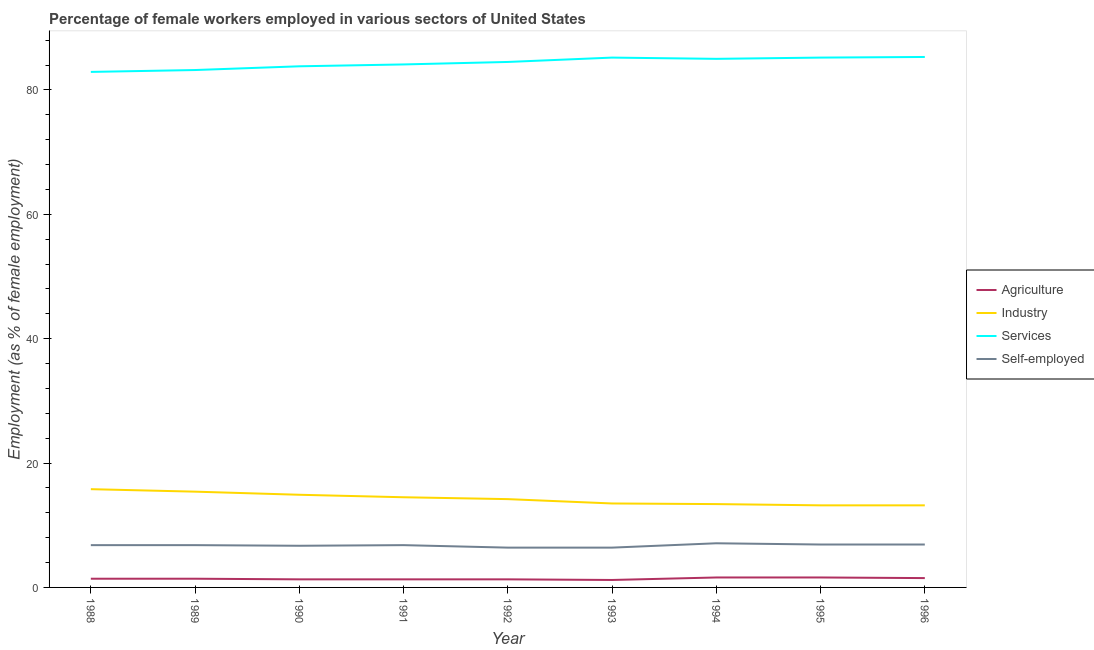Does the line corresponding to percentage of self employed female workers intersect with the line corresponding to percentage of female workers in industry?
Give a very brief answer. No. Is the number of lines equal to the number of legend labels?
Ensure brevity in your answer.  Yes. Across all years, what is the maximum percentage of self employed female workers?
Ensure brevity in your answer.  7.1. Across all years, what is the minimum percentage of female workers in industry?
Make the answer very short. 13.2. In which year was the percentage of female workers in agriculture maximum?
Ensure brevity in your answer.  1994. What is the total percentage of female workers in industry in the graph?
Give a very brief answer. 128.1. What is the difference between the percentage of female workers in industry in 1994 and that in 1995?
Your response must be concise. 0.2. What is the difference between the percentage of female workers in agriculture in 1988 and the percentage of self employed female workers in 1991?
Your answer should be compact. -5.4. What is the average percentage of female workers in industry per year?
Your answer should be very brief. 14.23. In the year 1996, what is the difference between the percentage of female workers in agriculture and percentage of female workers in industry?
Provide a succinct answer. -11.7. In how many years, is the percentage of female workers in services greater than 48 %?
Give a very brief answer. 9. What is the ratio of the percentage of female workers in services in 1990 to that in 1992?
Make the answer very short. 0.99. Is the difference between the percentage of female workers in industry in 1991 and 1996 greater than the difference between the percentage of female workers in services in 1991 and 1996?
Give a very brief answer. Yes. What is the difference between the highest and the second highest percentage of female workers in services?
Provide a succinct answer. 0.1. What is the difference between the highest and the lowest percentage of female workers in agriculture?
Your response must be concise. 0.4. In how many years, is the percentage of female workers in agriculture greater than the average percentage of female workers in agriculture taken over all years?
Your answer should be compact. 3. Is it the case that in every year, the sum of the percentage of female workers in services and percentage of self employed female workers is greater than the sum of percentage of female workers in industry and percentage of female workers in agriculture?
Keep it short and to the point. No. Is it the case that in every year, the sum of the percentage of female workers in agriculture and percentage of female workers in industry is greater than the percentage of female workers in services?
Keep it short and to the point. No. Does the percentage of female workers in industry monotonically increase over the years?
Offer a very short reply. No. Is the percentage of female workers in services strictly less than the percentage of female workers in industry over the years?
Give a very brief answer. No. What is the difference between two consecutive major ticks on the Y-axis?
Give a very brief answer. 20. Does the graph contain any zero values?
Your answer should be compact. No. Where does the legend appear in the graph?
Your answer should be compact. Center right. How many legend labels are there?
Provide a succinct answer. 4. What is the title of the graph?
Your answer should be compact. Percentage of female workers employed in various sectors of United States. What is the label or title of the X-axis?
Provide a short and direct response. Year. What is the label or title of the Y-axis?
Offer a very short reply. Employment (as % of female employment). What is the Employment (as % of female employment) of Agriculture in 1988?
Give a very brief answer. 1.4. What is the Employment (as % of female employment) of Industry in 1988?
Provide a short and direct response. 15.8. What is the Employment (as % of female employment) in Services in 1988?
Your response must be concise. 82.9. What is the Employment (as % of female employment) in Self-employed in 1988?
Make the answer very short. 6.8. What is the Employment (as % of female employment) in Agriculture in 1989?
Your answer should be very brief. 1.4. What is the Employment (as % of female employment) in Industry in 1989?
Provide a succinct answer. 15.4. What is the Employment (as % of female employment) of Services in 1989?
Your answer should be compact. 83.2. What is the Employment (as % of female employment) of Self-employed in 1989?
Make the answer very short. 6.8. What is the Employment (as % of female employment) of Agriculture in 1990?
Provide a short and direct response. 1.3. What is the Employment (as % of female employment) in Industry in 1990?
Ensure brevity in your answer.  14.9. What is the Employment (as % of female employment) in Services in 1990?
Ensure brevity in your answer.  83.8. What is the Employment (as % of female employment) in Self-employed in 1990?
Your answer should be compact. 6.7. What is the Employment (as % of female employment) of Agriculture in 1991?
Keep it short and to the point. 1.3. What is the Employment (as % of female employment) of Services in 1991?
Provide a short and direct response. 84.1. What is the Employment (as % of female employment) of Self-employed in 1991?
Your response must be concise. 6.8. What is the Employment (as % of female employment) in Agriculture in 1992?
Your answer should be compact. 1.3. What is the Employment (as % of female employment) in Industry in 1992?
Offer a very short reply. 14.2. What is the Employment (as % of female employment) of Services in 1992?
Offer a terse response. 84.5. What is the Employment (as % of female employment) of Self-employed in 1992?
Ensure brevity in your answer.  6.4. What is the Employment (as % of female employment) of Agriculture in 1993?
Provide a short and direct response. 1.2. What is the Employment (as % of female employment) in Industry in 1993?
Your response must be concise. 13.5. What is the Employment (as % of female employment) in Services in 1993?
Your answer should be very brief. 85.2. What is the Employment (as % of female employment) in Self-employed in 1993?
Ensure brevity in your answer.  6.4. What is the Employment (as % of female employment) of Agriculture in 1994?
Make the answer very short. 1.6. What is the Employment (as % of female employment) of Industry in 1994?
Ensure brevity in your answer.  13.4. What is the Employment (as % of female employment) in Self-employed in 1994?
Offer a terse response. 7.1. What is the Employment (as % of female employment) of Agriculture in 1995?
Give a very brief answer. 1.6. What is the Employment (as % of female employment) of Industry in 1995?
Make the answer very short. 13.2. What is the Employment (as % of female employment) of Services in 1995?
Give a very brief answer. 85.2. What is the Employment (as % of female employment) in Self-employed in 1995?
Make the answer very short. 6.9. What is the Employment (as % of female employment) of Industry in 1996?
Offer a very short reply. 13.2. What is the Employment (as % of female employment) of Services in 1996?
Give a very brief answer. 85.3. What is the Employment (as % of female employment) of Self-employed in 1996?
Your response must be concise. 6.9. Across all years, what is the maximum Employment (as % of female employment) in Agriculture?
Your answer should be compact. 1.6. Across all years, what is the maximum Employment (as % of female employment) of Industry?
Provide a succinct answer. 15.8. Across all years, what is the maximum Employment (as % of female employment) in Services?
Offer a terse response. 85.3. Across all years, what is the maximum Employment (as % of female employment) of Self-employed?
Offer a very short reply. 7.1. Across all years, what is the minimum Employment (as % of female employment) of Agriculture?
Provide a short and direct response. 1.2. Across all years, what is the minimum Employment (as % of female employment) in Industry?
Your answer should be compact. 13.2. Across all years, what is the minimum Employment (as % of female employment) of Services?
Provide a short and direct response. 82.9. Across all years, what is the minimum Employment (as % of female employment) in Self-employed?
Provide a succinct answer. 6.4. What is the total Employment (as % of female employment) in Industry in the graph?
Provide a short and direct response. 128.1. What is the total Employment (as % of female employment) in Services in the graph?
Ensure brevity in your answer.  759.2. What is the total Employment (as % of female employment) of Self-employed in the graph?
Ensure brevity in your answer.  60.8. What is the difference between the Employment (as % of female employment) of Agriculture in 1988 and that in 1989?
Your response must be concise. 0. What is the difference between the Employment (as % of female employment) of Industry in 1988 and that in 1989?
Ensure brevity in your answer.  0.4. What is the difference between the Employment (as % of female employment) in Services in 1988 and that in 1989?
Keep it short and to the point. -0.3. What is the difference between the Employment (as % of female employment) in Self-employed in 1988 and that in 1990?
Give a very brief answer. 0.1. What is the difference between the Employment (as % of female employment) in Agriculture in 1988 and that in 1991?
Provide a short and direct response. 0.1. What is the difference between the Employment (as % of female employment) of Industry in 1988 and that in 1991?
Your answer should be compact. 1.3. What is the difference between the Employment (as % of female employment) of Industry in 1988 and that in 1992?
Provide a succinct answer. 1.6. What is the difference between the Employment (as % of female employment) in Services in 1988 and that in 1992?
Offer a very short reply. -1.6. What is the difference between the Employment (as % of female employment) in Self-employed in 1988 and that in 1992?
Give a very brief answer. 0.4. What is the difference between the Employment (as % of female employment) in Services in 1988 and that in 1993?
Provide a succinct answer. -2.3. What is the difference between the Employment (as % of female employment) in Self-employed in 1988 and that in 1993?
Ensure brevity in your answer.  0.4. What is the difference between the Employment (as % of female employment) of Services in 1988 and that in 1994?
Keep it short and to the point. -2.1. What is the difference between the Employment (as % of female employment) in Industry in 1988 and that in 1995?
Ensure brevity in your answer.  2.6. What is the difference between the Employment (as % of female employment) of Self-employed in 1988 and that in 1995?
Ensure brevity in your answer.  -0.1. What is the difference between the Employment (as % of female employment) in Self-employed in 1988 and that in 1996?
Offer a terse response. -0.1. What is the difference between the Employment (as % of female employment) in Agriculture in 1989 and that in 1990?
Ensure brevity in your answer.  0.1. What is the difference between the Employment (as % of female employment) of Industry in 1989 and that in 1990?
Your answer should be compact. 0.5. What is the difference between the Employment (as % of female employment) of Services in 1989 and that in 1990?
Offer a very short reply. -0.6. What is the difference between the Employment (as % of female employment) in Self-employed in 1989 and that in 1990?
Your answer should be very brief. 0.1. What is the difference between the Employment (as % of female employment) of Agriculture in 1989 and that in 1991?
Provide a short and direct response. 0.1. What is the difference between the Employment (as % of female employment) in Industry in 1989 and that in 1991?
Offer a terse response. 0.9. What is the difference between the Employment (as % of female employment) of Services in 1989 and that in 1991?
Ensure brevity in your answer.  -0.9. What is the difference between the Employment (as % of female employment) in Agriculture in 1989 and that in 1992?
Keep it short and to the point. 0.1. What is the difference between the Employment (as % of female employment) in Services in 1989 and that in 1992?
Offer a terse response. -1.3. What is the difference between the Employment (as % of female employment) of Self-employed in 1989 and that in 1992?
Your answer should be compact. 0.4. What is the difference between the Employment (as % of female employment) of Industry in 1989 and that in 1994?
Your answer should be compact. 2. What is the difference between the Employment (as % of female employment) in Services in 1989 and that in 1995?
Offer a very short reply. -2. What is the difference between the Employment (as % of female employment) of Self-employed in 1989 and that in 1995?
Your response must be concise. -0.1. What is the difference between the Employment (as % of female employment) of Industry in 1989 and that in 1996?
Provide a succinct answer. 2.2. What is the difference between the Employment (as % of female employment) in Industry in 1990 and that in 1991?
Offer a very short reply. 0.4. What is the difference between the Employment (as % of female employment) of Agriculture in 1990 and that in 1992?
Ensure brevity in your answer.  0. What is the difference between the Employment (as % of female employment) of Services in 1990 and that in 1992?
Provide a short and direct response. -0.7. What is the difference between the Employment (as % of female employment) in Agriculture in 1990 and that in 1993?
Ensure brevity in your answer.  0.1. What is the difference between the Employment (as % of female employment) of Self-employed in 1990 and that in 1993?
Make the answer very short. 0.3. What is the difference between the Employment (as % of female employment) of Services in 1990 and that in 1994?
Your answer should be compact. -1.2. What is the difference between the Employment (as % of female employment) of Agriculture in 1990 and that in 1996?
Give a very brief answer. -0.2. What is the difference between the Employment (as % of female employment) of Services in 1990 and that in 1996?
Make the answer very short. -1.5. What is the difference between the Employment (as % of female employment) of Self-employed in 1990 and that in 1996?
Offer a terse response. -0.2. What is the difference between the Employment (as % of female employment) in Industry in 1991 and that in 1992?
Your answer should be compact. 0.3. What is the difference between the Employment (as % of female employment) in Agriculture in 1991 and that in 1993?
Your response must be concise. 0.1. What is the difference between the Employment (as % of female employment) of Industry in 1991 and that in 1993?
Offer a very short reply. 1. What is the difference between the Employment (as % of female employment) in Industry in 1991 and that in 1994?
Provide a succinct answer. 1.1. What is the difference between the Employment (as % of female employment) of Services in 1991 and that in 1994?
Your response must be concise. -0.9. What is the difference between the Employment (as % of female employment) in Self-employed in 1991 and that in 1995?
Give a very brief answer. -0.1. What is the difference between the Employment (as % of female employment) of Industry in 1991 and that in 1996?
Provide a succinct answer. 1.3. What is the difference between the Employment (as % of female employment) in Self-employed in 1991 and that in 1996?
Your answer should be very brief. -0.1. What is the difference between the Employment (as % of female employment) of Industry in 1992 and that in 1993?
Give a very brief answer. 0.7. What is the difference between the Employment (as % of female employment) in Services in 1992 and that in 1993?
Your answer should be compact. -0.7. What is the difference between the Employment (as % of female employment) of Agriculture in 1992 and that in 1994?
Your answer should be compact. -0.3. What is the difference between the Employment (as % of female employment) of Industry in 1992 and that in 1994?
Offer a terse response. 0.8. What is the difference between the Employment (as % of female employment) in Agriculture in 1992 and that in 1995?
Provide a succinct answer. -0.3. What is the difference between the Employment (as % of female employment) of Self-employed in 1992 and that in 1995?
Your response must be concise. -0.5. What is the difference between the Employment (as % of female employment) in Agriculture in 1992 and that in 1996?
Your response must be concise. -0.2. What is the difference between the Employment (as % of female employment) of Industry in 1992 and that in 1996?
Provide a short and direct response. 1. What is the difference between the Employment (as % of female employment) of Agriculture in 1993 and that in 1994?
Provide a short and direct response. -0.4. What is the difference between the Employment (as % of female employment) of Services in 1993 and that in 1994?
Provide a short and direct response. 0.2. What is the difference between the Employment (as % of female employment) of Self-employed in 1993 and that in 1994?
Make the answer very short. -0.7. What is the difference between the Employment (as % of female employment) in Agriculture in 1993 and that in 1995?
Provide a short and direct response. -0.4. What is the difference between the Employment (as % of female employment) in Services in 1993 and that in 1995?
Ensure brevity in your answer.  0. What is the difference between the Employment (as % of female employment) in Self-employed in 1993 and that in 1996?
Your response must be concise. -0.5. What is the difference between the Employment (as % of female employment) of Industry in 1994 and that in 1995?
Give a very brief answer. 0.2. What is the difference between the Employment (as % of female employment) of Services in 1994 and that in 1996?
Provide a succinct answer. -0.3. What is the difference between the Employment (as % of female employment) of Industry in 1995 and that in 1996?
Your answer should be very brief. 0. What is the difference between the Employment (as % of female employment) of Agriculture in 1988 and the Employment (as % of female employment) of Services in 1989?
Offer a terse response. -81.8. What is the difference between the Employment (as % of female employment) in Industry in 1988 and the Employment (as % of female employment) in Services in 1989?
Offer a very short reply. -67.4. What is the difference between the Employment (as % of female employment) in Services in 1988 and the Employment (as % of female employment) in Self-employed in 1989?
Make the answer very short. 76.1. What is the difference between the Employment (as % of female employment) in Agriculture in 1988 and the Employment (as % of female employment) in Services in 1990?
Your answer should be compact. -82.4. What is the difference between the Employment (as % of female employment) in Agriculture in 1988 and the Employment (as % of female employment) in Self-employed in 1990?
Your answer should be very brief. -5.3. What is the difference between the Employment (as % of female employment) of Industry in 1988 and the Employment (as % of female employment) of Services in 1990?
Offer a terse response. -68. What is the difference between the Employment (as % of female employment) of Services in 1988 and the Employment (as % of female employment) of Self-employed in 1990?
Your answer should be very brief. 76.2. What is the difference between the Employment (as % of female employment) of Agriculture in 1988 and the Employment (as % of female employment) of Industry in 1991?
Offer a very short reply. -13.1. What is the difference between the Employment (as % of female employment) of Agriculture in 1988 and the Employment (as % of female employment) of Services in 1991?
Give a very brief answer. -82.7. What is the difference between the Employment (as % of female employment) of Agriculture in 1988 and the Employment (as % of female employment) of Self-employed in 1991?
Offer a terse response. -5.4. What is the difference between the Employment (as % of female employment) of Industry in 1988 and the Employment (as % of female employment) of Services in 1991?
Give a very brief answer. -68.3. What is the difference between the Employment (as % of female employment) of Industry in 1988 and the Employment (as % of female employment) of Self-employed in 1991?
Your response must be concise. 9. What is the difference between the Employment (as % of female employment) in Services in 1988 and the Employment (as % of female employment) in Self-employed in 1991?
Provide a succinct answer. 76.1. What is the difference between the Employment (as % of female employment) of Agriculture in 1988 and the Employment (as % of female employment) of Services in 1992?
Provide a short and direct response. -83.1. What is the difference between the Employment (as % of female employment) of Agriculture in 1988 and the Employment (as % of female employment) of Self-employed in 1992?
Your response must be concise. -5. What is the difference between the Employment (as % of female employment) in Industry in 1988 and the Employment (as % of female employment) in Services in 1992?
Ensure brevity in your answer.  -68.7. What is the difference between the Employment (as % of female employment) in Services in 1988 and the Employment (as % of female employment) in Self-employed in 1992?
Keep it short and to the point. 76.5. What is the difference between the Employment (as % of female employment) in Agriculture in 1988 and the Employment (as % of female employment) in Services in 1993?
Give a very brief answer. -83.8. What is the difference between the Employment (as % of female employment) in Industry in 1988 and the Employment (as % of female employment) in Services in 1993?
Your response must be concise. -69.4. What is the difference between the Employment (as % of female employment) of Services in 1988 and the Employment (as % of female employment) of Self-employed in 1993?
Make the answer very short. 76.5. What is the difference between the Employment (as % of female employment) of Agriculture in 1988 and the Employment (as % of female employment) of Industry in 1994?
Provide a succinct answer. -12. What is the difference between the Employment (as % of female employment) in Agriculture in 1988 and the Employment (as % of female employment) in Services in 1994?
Your answer should be very brief. -83.6. What is the difference between the Employment (as % of female employment) in Industry in 1988 and the Employment (as % of female employment) in Services in 1994?
Your answer should be very brief. -69.2. What is the difference between the Employment (as % of female employment) of Services in 1988 and the Employment (as % of female employment) of Self-employed in 1994?
Your answer should be very brief. 75.8. What is the difference between the Employment (as % of female employment) in Agriculture in 1988 and the Employment (as % of female employment) in Industry in 1995?
Your response must be concise. -11.8. What is the difference between the Employment (as % of female employment) in Agriculture in 1988 and the Employment (as % of female employment) in Services in 1995?
Provide a short and direct response. -83.8. What is the difference between the Employment (as % of female employment) of Agriculture in 1988 and the Employment (as % of female employment) of Self-employed in 1995?
Make the answer very short. -5.5. What is the difference between the Employment (as % of female employment) in Industry in 1988 and the Employment (as % of female employment) in Services in 1995?
Provide a succinct answer. -69.4. What is the difference between the Employment (as % of female employment) of Industry in 1988 and the Employment (as % of female employment) of Self-employed in 1995?
Make the answer very short. 8.9. What is the difference between the Employment (as % of female employment) of Services in 1988 and the Employment (as % of female employment) of Self-employed in 1995?
Give a very brief answer. 76. What is the difference between the Employment (as % of female employment) in Agriculture in 1988 and the Employment (as % of female employment) in Services in 1996?
Offer a very short reply. -83.9. What is the difference between the Employment (as % of female employment) in Industry in 1988 and the Employment (as % of female employment) in Services in 1996?
Provide a short and direct response. -69.5. What is the difference between the Employment (as % of female employment) of Industry in 1988 and the Employment (as % of female employment) of Self-employed in 1996?
Offer a terse response. 8.9. What is the difference between the Employment (as % of female employment) in Services in 1988 and the Employment (as % of female employment) in Self-employed in 1996?
Provide a succinct answer. 76. What is the difference between the Employment (as % of female employment) in Agriculture in 1989 and the Employment (as % of female employment) in Industry in 1990?
Ensure brevity in your answer.  -13.5. What is the difference between the Employment (as % of female employment) in Agriculture in 1989 and the Employment (as % of female employment) in Services in 1990?
Give a very brief answer. -82.4. What is the difference between the Employment (as % of female employment) of Agriculture in 1989 and the Employment (as % of female employment) of Self-employed in 1990?
Provide a short and direct response. -5.3. What is the difference between the Employment (as % of female employment) in Industry in 1989 and the Employment (as % of female employment) in Services in 1990?
Your response must be concise. -68.4. What is the difference between the Employment (as % of female employment) in Industry in 1989 and the Employment (as % of female employment) in Self-employed in 1990?
Your answer should be very brief. 8.7. What is the difference between the Employment (as % of female employment) of Services in 1989 and the Employment (as % of female employment) of Self-employed in 1990?
Your answer should be very brief. 76.5. What is the difference between the Employment (as % of female employment) in Agriculture in 1989 and the Employment (as % of female employment) in Services in 1991?
Offer a terse response. -82.7. What is the difference between the Employment (as % of female employment) in Agriculture in 1989 and the Employment (as % of female employment) in Self-employed in 1991?
Offer a very short reply. -5.4. What is the difference between the Employment (as % of female employment) in Industry in 1989 and the Employment (as % of female employment) in Services in 1991?
Provide a short and direct response. -68.7. What is the difference between the Employment (as % of female employment) of Services in 1989 and the Employment (as % of female employment) of Self-employed in 1991?
Offer a very short reply. 76.4. What is the difference between the Employment (as % of female employment) of Agriculture in 1989 and the Employment (as % of female employment) of Services in 1992?
Your response must be concise. -83.1. What is the difference between the Employment (as % of female employment) of Industry in 1989 and the Employment (as % of female employment) of Services in 1992?
Offer a very short reply. -69.1. What is the difference between the Employment (as % of female employment) of Industry in 1989 and the Employment (as % of female employment) of Self-employed in 1992?
Give a very brief answer. 9. What is the difference between the Employment (as % of female employment) of Services in 1989 and the Employment (as % of female employment) of Self-employed in 1992?
Provide a succinct answer. 76.8. What is the difference between the Employment (as % of female employment) in Agriculture in 1989 and the Employment (as % of female employment) in Industry in 1993?
Make the answer very short. -12.1. What is the difference between the Employment (as % of female employment) of Agriculture in 1989 and the Employment (as % of female employment) of Services in 1993?
Provide a succinct answer. -83.8. What is the difference between the Employment (as % of female employment) of Agriculture in 1989 and the Employment (as % of female employment) of Self-employed in 1993?
Your answer should be very brief. -5. What is the difference between the Employment (as % of female employment) in Industry in 1989 and the Employment (as % of female employment) in Services in 1993?
Provide a succinct answer. -69.8. What is the difference between the Employment (as % of female employment) of Services in 1989 and the Employment (as % of female employment) of Self-employed in 1993?
Your answer should be very brief. 76.8. What is the difference between the Employment (as % of female employment) of Agriculture in 1989 and the Employment (as % of female employment) of Services in 1994?
Provide a succinct answer. -83.6. What is the difference between the Employment (as % of female employment) of Industry in 1989 and the Employment (as % of female employment) of Services in 1994?
Give a very brief answer. -69.6. What is the difference between the Employment (as % of female employment) in Services in 1989 and the Employment (as % of female employment) in Self-employed in 1994?
Keep it short and to the point. 76.1. What is the difference between the Employment (as % of female employment) of Agriculture in 1989 and the Employment (as % of female employment) of Industry in 1995?
Your response must be concise. -11.8. What is the difference between the Employment (as % of female employment) of Agriculture in 1989 and the Employment (as % of female employment) of Services in 1995?
Offer a very short reply. -83.8. What is the difference between the Employment (as % of female employment) in Industry in 1989 and the Employment (as % of female employment) in Services in 1995?
Your answer should be compact. -69.8. What is the difference between the Employment (as % of female employment) in Industry in 1989 and the Employment (as % of female employment) in Self-employed in 1995?
Ensure brevity in your answer.  8.5. What is the difference between the Employment (as % of female employment) in Services in 1989 and the Employment (as % of female employment) in Self-employed in 1995?
Offer a terse response. 76.3. What is the difference between the Employment (as % of female employment) in Agriculture in 1989 and the Employment (as % of female employment) in Industry in 1996?
Give a very brief answer. -11.8. What is the difference between the Employment (as % of female employment) of Agriculture in 1989 and the Employment (as % of female employment) of Services in 1996?
Keep it short and to the point. -83.9. What is the difference between the Employment (as % of female employment) of Agriculture in 1989 and the Employment (as % of female employment) of Self-employed in 1996?
Give a very brief answer. -5.5. What is the difference between the Employment (as % of female employment) of Industry in 1989 and the Employment (as % of female employment) of Services in 1996?
Keep it short and to the point. -69.9. What is the difference between the Employment (as % of female employment) in Industry in 1989 and the Employment (as % of female employment) in Self-employed in 1996?
Keep it short and to the point. 8.5. What is the difference between the Employment (as % of female employment) in Services in 1989 and the Employment (as % of female employment) in Self-employed in 1996?
Provide a short and direct response. 76.3. What is the difference between the Employment (as % of female employment) of Agriculture in 1990 and the Employment (as % of female employment) of Industry in 1991?
Give a very brief answer. -13.2. What is the difference between the Employment (as % of female employment) of Agriculture in 1990 and the Employment (as % of female employment) of Services in 1991?
Your answer should be very brief. -82.8. What is the difference between the Employment (as % of female employment) of Agriculture in 1990 and the Employment (as % of female employment) of Self-employed in 1991?
Offer a terse response. -5.5. What is the difference between the Employment (as % of female employment) in Industry in 1990 and the Employment (as % of female employment) in Services in 1991?
Make the answer very short. -69.2. What is the difference between the Employment (as % of female employment) in Agriculture in 1990 and the Employment (as % of female employment) in Services in 1992?
Ensure brevity in your answer.  -83.2. What is the difference between the Employment (as % of female employment) in Industry in 1990 and the Employment (as % of female employment) in Services in 1992?
Offer a terse response. -69.6. What is the difference between the Employment (as % of female employment) of Industry in 1990 and the Employment (as % of female employment) of Self-employed in 1992?
Keep it short and to the point. 8.5. What is the difference between the Employment (as % of female employment) of Services in 1990 and the Employment (as % of female employment) of Self-employed in 1992?
Ensure brevity in your answer.  77.4. What is the difference between the Employment (as % of female employment) of Agriculture in 1990 and the Employment (as % of female employment) of Services in 1993?
Offer a very short reply. -83.9. What is the difference between the Employment (as % of female employment) in Industry in 1990 and the Employment (as % of female employment) in Services in 1993?
Offer a very short reply. -70.3. What is the difference between the Employment (as % of female employment) in Industry in 1990 and the Employment (as % of female employment) in Self-employed in 1993?
Provide a succinct answer. 8.5. What is the difference between the Employment (as % of female employment) in Services in 1990 and the Employment (as % of female employment) in Self-employed in 1993?
Your answer should be compact. 77.4. What is the difference between the Employment (as % of female employment) in Agriculture in 1990 and the Employment (as % of female employment) in Services in 1994?
Your answer should be very brief. -83.7. What is the difference between the Employment (as % of female employment) of Agriculture in 1990 and the Employment (as % of female employment) of Self-employed in 1994?
Provide a succinct answer. -5.8. What is the difference between the Employment (as % of female employment) of Industry in 1990 and the Employment (as % of female employment) of Services in 1994?
Ensure brevity in your answer.  -70.1. What is the difference between the Employment (as % of female employment) of Services in 1990 and the Employment (as % of female employment) of Self-employed in 1994?
Your response must be concise. 76.7. What is the difference between the Employment (as % of female employment) of Agriculture in 1990 and the Employment (as % of female employment) of Services in 1995?
Make the answer very short. -83.9. What is the difference between the Employment (as % of female employment) in Agriculture in 1990 and the Employment (as % of female employment) in Self-employed in 1995?
Give a very brief answer. -5.6. What is the difference between the Employment (as % of female employment) in Industry in 1990 and the Employment (as % of female employment) in Services in 1995?
Your response must be concise. -70.3. What is the difference between the Employment (as % of female employment) in Industry in 1990 and the Employment (as % of female employment) in Self-employed in 1995?
Provide a short and direct response. 8. What is the difference between the Employment (as % of female employment) in Services in 1990 and the Employment (as % of female employment) in Self-employed in 1995?
Keep it short and to the point. 76.9. What is the difference between the Employment (as % of female employment) in Agriculture in 1990 and the Employment (as % of female employment) in Industry in 1996?
Give a very brief answer. -11.9. What is the difference between the Employment (as % of female employment) of Agriculture in 1990 and the Employment (as % of female employment) of Services in 1996?
Make the answer very short. -84. What is the difference between the Employment (as % of female employment) of Industry in 1990 and the Employment (as % of female employment) of Services in 1996?
Ensure brevity in your answer.  -70.4. What is the difference between the Employment (as % of female employment) in Services in 1990 and the Employment (as % of female employment) in Self-employed in 1996?
Provide a short and direct response. 76.9. What is the difference between the Employment (as % of female employment) of Agriculture in 1991 and the Employment (as % of female employment) of Industry in 1992?
Your response must be concise. -12.9. What is the difference between the Employment (as % of female employment) in Agriculture in 1991 and the Employment (as % of female employment) in Services in 1992?
Provide a succinct answer. -83.2. What is the difference between the Employment (as % of female employment) in Industry in 1991 and the Employment (as % of female employment) in Services in 1992?
Your response must be concise. -70. What is the difference between the Employment (as % of female employment) in Services in 1991 and the Employment (as % of female employment) in Self-employed in 1992?
Your answer should be very brief. 77.7. What is the difference between the Employment (as % of female employment) of Agriculture in 1991 and the Employment (as % of female employment) of Services in 1993?
Your answer should be very brief. -83.9. What is the difference between the Employment (as % of female employment) of Agriculture in 1991 and the Employment (as % of female employment) of Self-employed in 1993?
Provide a succinct answer. -5.1. What is the difference between the Employment (as % of female employment) in Industry in 1991 and the Employment (as % of female employment) in Services in 1993?
Offer a very short reply. -70.7. What is the difference between the Employment (as % of female employment) of Industry in 1991 and the Employment (as % of female employment) of Self-employed in 1993?
Ensure brevity in your answer.  8.1. What is the difference between the Employment (as % of female employment) in Services in 1991 and the Employment (as % of female employment) in Self-employed in 1993?
Keep it short and to the point. 77.7. What is the difference between the Employment (as % of female employment) in Agriculture in 1991 and the Employment (as % of female employment) in Services in 1994?
Keep it short and to the point. -83.7. What is the difference between the Employment (as % of female employment) in Industry in 1991 and the Employment (as % of female employment) in Services in 1994?
Provide a short and direct response. -70.5. What is the difference between the Employment (as % of female employment) of Industry in 1991 and the Employment (as % of female employment) of Self-employed in 1994?
Give a very brief answer. 7.4. What is the difference between the Employment (as % of female employment) of Services in 1991 and the Employment (as % of female employment) of Self-employed in 1994?
Offer a terse response. 77. What is the difference between the Employment (as % of female employment) in Agriculture in 1991 and the Employment (as % of female employment) in Industry in 1995?
Offer a very short reply. -11.9. What is the difference between the Employment (as % of female employment) in Agriculture in 1991 and the Employment (as % of female employment) in Services in 1995?
Give a very brief answer. -83.9. What is the difference between the Employment (as % of female employment) of Industry in 1991 and the Employment (as % of female employment) of Services in 1995?
Provide a short and direct response. -70.7. What is the difference between the Employment (as % of female employment) of Industry in 1991 and the Employment (as % of female employment) of Self-employed in 1995?
Your answer should be compact. 7.6. What is the difference between the Employment (as % of female employment) of Services in 1991 and the Employment (as % of female employment) of Self-employed in 1995?
Give a very brief answer. 77.2. What is the difference between the Employment (as % of female employment) in Agriculture in 1991 and the Employment (as % of female employment) in Industry in 1996?
Ensure brevity in your answer.  -11.9. What is the difference between the Employment (as % of female employment) of Agriculture in 1991 and the Employment (as % of female employment) of Services in 1996?
Make the answer very short. -84. What is the difference between the Employment (as % of female employment) of Industry in 1991 and the Employment (as % of female employment) of Services in 1996?
Offer a very short reply. -70.8. What is the difference between the Employment (as % of female employment) in Industry in 1991 and the Employment (as % of female employment) in Self-employed in 1996?
Provide a short and direct response. 7.6. What is the difference between the Employment (as % of female employment) of Services in 1991 and the Employment (as % of female employment) of Self-employed in 1996?
Your answer should be compact. 77.2. What is the difference between the Employment (as % of female employment) of Agriculture in 1992 and the Employment (as % of female employment) of Services in 1993?
Keep it short and to the point. -83.9. What is the difference between the Employment (as % of female employment) of Agriculture in 1992 and the Employment (as % of female employment) of Self-employed in 1993?
Give a very brief answer. -5.1. What is the difference between the Employment (as % of female employment) of Industry in 1992 and the Employment (as % of female employment) of Services in 1993?
Your response must be concise. -71. What is the difference between the Employment (as % of female employment) in Services in 1992 and the Employment (as % of female employment) in Self-employed in 1993?
Your answer should be compact. 78.1. What is the difference between the Employment (as % of female employment) in Agriculture in 1992 and the Employment (as % of female employment) in Services in 1994?
Keep it short and to the point. -83.7. What is the difference between the Employment (as % of female employment) of Agriculture in 1992 and the Employment (as % of female employment) of Self-employed in 1994?
Provide a short and direct response. -5.8. What is the difference between the Employment (as % of female employment) in Industry in 1992 and the Employment (as % of female employment) in Services in 1994?
Keep it short and to the point. -70.8. What is the difference between the Employment (as % of female employment) of Industry in 1992 and the Employment (as % of female employment) of Self-employed in 1994?
Give a very brief answer. 7.1. What is the difference between the Employment (as % of female employment) in Services in 1992 and the Employment (as % of female employment) in Self-employed in 1994?
Offer a terse response. 77.4. What is the difference between the Employment (as % of female employment) in Agriculture in 1992 and the Employment (as % of female employment) in Industry in 1995?
Your answer should be very brief. -11.9. What is the difference between the Employment (as % of female employment) in Agriculture in 1992 and the Employment (as % of female employment) in Services in 1995?
Ensure brevity in your answer.  -83.9. What is the difference between the Employment (as % of female employment) of Industry in 1992 and the Employment (as % of female employment) of Services in 1995?
Make the answer very short. -71. What is the difference between the Employment (as % of female employment) of Services in 1992 and the Employment (as % of female employment) of Self-employed in 1995?
Keep it short and to the point. 77.6. What is the difference between the Employment (as % of female employment) of Agriculture in 1992 and the Employment (as % of female employment) of Services in 1996?
Provide a short and direct response. -84. What is the difference between the Employment (as % of female employment) in Agriculture in 1992 and the Employment (as % of female employment) in Self-employed in 1996?
Keep it short and to the point. -5.6. What is the difference between the Employment (as % of female employment) in Industry in 1992 and the Employment (as % of female employment) in Services in 1996?
Provide a short and direct response. -71.1. What is the difference between the Employment (as % of female employment) in Industry in 1992 and the Employment (as % of female employment) in Self-employed in 1996?
Give a very brief answer. 7.3. What is the difference between the Employment (as % of female employment) in Services in 1992 and the Employment (as % of female employment) in Self-employed in 1996?
Offer a very short reply. 77.6. What is the difference between the Employment (as % of female employment) in Agriculture in 1993 and the Employment (as % of female employment) in Services in 1994?
Your response must be concise. -83.8. What is the difference between the Employment (as % of female employment) in Industry in 1993 and the Employment (as % of female employment) in Services in 1994?
Make the answer very short. -71.5. What is the difference between the Employment (as % of female employment) of Industry in 1993 and the Employment (as % of female employment) of Self-employed in 1994?
Offer a very short reply. 6.4. What is the difference between the Employment (as % of female employment) in Services in 1993 and the Employment (as % of female employment) in Self-employed in 1994?
Provide a short and direct response. 78.1. What is the difference between the Employment (as % of female employment) in Agriculture in 1993 and the Employment (as % of female employment) in Industry in 1995?
Ensure brevity in your answer.  -12. What is the difference between the Employment (as % of female employment) in Agriculture in 1993 and the Employment (as % of female employment) in Services in 1995?
Your answer should be compact. -84. What is the difference between the Employment (as % of female employment) of Industry in 1993 and the Employment (as % of female employment) of Services in 1995?
Offer a very short reply. -71.7. What is the difference between the Employment (as % of female employment) in Services in 1993 and the Employment (as % of female employment) in Self-employed in 1995?
Give a very brief answer. 78.3. What is the difference between the Employment (as % of female employment) in Agriculture in 1993 and the Employment (as % of female employment) in Industry in 1996?
Your response must be concise. -12. What is the difference between the Employment (as % of female employment) in Agriculture in 1993 and the Employment (as % of female employment) in Services in 1996?
Your answer should be compact. -84.1. What is the difference between the Employment (as % of female employment) of Industry in 1993 and the Employment (as % of female employment) of Services in 1996?
Ensure brevity in your answer.  -71.8. What is the difference between the Employment (as % of female employment) in Services in 1993 and the Employment (as % of female employment) in Self-employed in 1996?
Offer a very short reply. 78.3. What is the difference between the Employment (as % of female employment) of Agriculture in 1994 and the Employment (as % of female employment) of Industry in 1995?
Your answer should be very brief. -11.6. What is the difference between the Employment (as % of female employment) of Agriculture in 1994 and the Employment (as % of female employment) of Services in 1995?
Give a very brief answer. -83.6. What is the difference between the Employment (as % of female employment) of Agriculture in 1994 and the Employment (as % of female employment) of Self-employed in 1995?
Ensure brevity in your answer.  -5.3. What is the difference between the Employment (as % of female employment) in Industry in 1994 and the Employment (as % of female employment) in Services in 1995?
Offer a terse response. -71.8. What is the difference between the Employment (as % of female employment) in Services in 1994 and the Employment (as % of female employment) in Self-employed in 1995?
Ensure brevity in your answer.  78.1. What is the difference between the Employment (as % of female employment) in Agriculture in 1994 and the Employment (as % of female employment) in Industry in 1996?
Your response must be concise. -11.6. What is the difference between the Employment (as % of female employment) in Agriculture in 1994 and the Employment (as % of female employment) in Services in 1996?
Your answer should be very brief. -83.7. What is the difference between the Employment (as % of female employment) in Industry in 1994 and the Employment (as % of female employment) in Services in 1996?
Keep it short and to the point. -71.9. What is the difference between the Employment (as % of female employment) of Services in 1994 and the Employment (as % of female employment) of Self-employed in 1996?
Your answer should be very brief. 78.1. What is the difference between the Employment (as % of female employment) of Agriculture in 1995 and the Employment (as % of female employment) of Services in 1996?
Your answer should be compact. -83.7. What is the difference between the Employment (as % of female employment) in Agriculture in 1995 and the Employment (as % of female employment) in Self-employed in 1996?
Give a very brief answer. -5.3. What is the difference between the Employment (as % of female employment) of Industry in 1995 and the Employment (as % of female employment) of Services in 1996?
Your response must be concise. -72.1. What is the difference between the Employment (as % of female employment) of Services in 1995 and the Employment (as % of female employment) of Self-employed in 1996?
Offer a very short reply. 78.3. What is the average Employment (as % of female employment) of Agriculture per year?
Provide a succinct answer. 1.4. What is the average Employment (as % of female employment) in Industry per year?
Offer a very short reply. 14.23. What is the average Employment (as % of female employment) in Services per year?
Your answer should be very brief. 84.36. What is the average Employment (as % of female employment) in Self-employed per year?
Your answer should be very brief. 6.76. In the year 1988, what is the difference between the Employment (as % of female employment) in Agriculture and Employment (as % of female employment) in Industry?
Ensure brevity in your answer.  -14.4. In the year 1988, what is the difference between the Employment (as % of female employment) in Agriculture and Employment (as % of female employment) in Services?
Your answer should be very brief. -81.5. In the year 1988, what is the difference between the Employment (as % of female employment) of Agriculture and Employment (as % of female employment) of Self-employed?
Your answer should be very brief. -5.4. In the year 1988, what is the difference between the Employment (as % of female employment) in Industry and Employment (as % of female employment) in Services?
Keep it short and to the point. -67.1. In the year 1988, what is the difference between the Employment (as % of female employment) of Industry and Employment (as % of female employment) of Self-employed?
Provide a succinct answer. 9. In the year 1988, what is the difference between the Employment (as % of female employment) in Services and Employment (as % of female employment) in Self-employed?
Provide a succinct answer. 76.1. In the year 1989, what is the difference between the Employment (as % of female employment) in Agriculture and Employment (as % of female employment) in Services?
Make the answer very short. -81.8. In the year 1989, what is the difference between the Employment (as % of female employment) in Agriculture and Employment (as % of female employment) in Self-employed?
Provide a succinct answer. -5.4. In the year 1989, what is the difference between the Employment (as % of female employment) of Industry and Employment (as % of female employment) of Services?
Provide a succinct answer. -67.8. In the year 1989, what is the difference between the Employment (as % of female employment) of Industry and Employment (as % of female employment) of Self-employed?
Your answer should be very brief. 8.6. In the year 1989, what is the difference between the Employment (as % of female employment) in Services and Employment (as % of female employment) in Self-employed?
Offer a very short reply. 76.4. In the year 1990, what is the difference between the Employment (as % of female employment) of Agriculture and Employment (as % of female employment) of Services?
Provide a short and direct response. -82.5. In the year 1990, what is the difference between the Employment (as % of female employment) in Agriculture and Employment (as % of female employment) in Self-employed?
Ensure brevity in your answer.  -5.4. In the year 1990, what is the difference between the Employment (as % of female employment) of Industry and Employment (as % of female employment) of Services?
Provide a succinct answer. -68.9. In the year 1990, what is the difference between the Employment (as % of female employment) in Industry and Employment (as % of female employment) in Self-employed?
Make the answer very short. 8.2. In the year 1990, what is the difference between the Employment (as % of female employment) in Services and Employment (as % of female employment) in Self-employed?
Offer a terse response. 77.1. In the year 1991, what is the difference between the Employment (as % of female employment) of Agriculture and Employment (as % of female employment) of Services?
Make the answer very short. -82.8. In the year 1991, what is the difference between the Employment (as % of female employment) of Agriculture and Employment (as % of female employment) of Self-employed?
Give a very brief answer. -5.5. In the year 1991, what is the difference between the Employment (as % of female employment) in Industry and Employment (as % of female employment) in Services?
Offer a terse response. -69.6. In the year 1991, what is the difference between the Employment (as % of female employment) in Industry and Employment (as % of female employment) in Self-employed?
Ensure brevity in your answer.  7.7. In the year 1991, what is the difference between the Employment (as % of female employment) in Services and Employment (as % of female employment) in Self-employed?
Make the answer very short. 77.3. In the year 1992, what is the difference between the Employment (as % of female employment) in Agriculture and Employment (as % of female employment) in Industry?
Give a very brief answer. -12.9. In the year 1992, what is the difference between the Employment (as % of female employment) of Agriculture and Employment (as % of female employment) of Services?
Provide a succinct answer. -83.2. In the year 1992, what is the difference between the Employment (as % of female employment) in Industry and Employment (as % of female employment) in Services?
Provide a short and direct response. -70.3. In the year 1992, what is the difference between the Employment (as % of female employment) in Services and Employment (as % of female employment) in Self-employed?
Provide a succinct answer. 78.1. In the year 1993, what is the difference between the Employment (as % of female employment) of Agriculture and Employment (as % of female employment) of Services?
Provide a short and direct response. -84. In the year 1993, what is the difference between the Employment (as % of female employment) of Agriculture and Employment (as % of female employment) of Self-employed?
Offer a very short reply. -5.2. In the year 1993, what is the difference between the Employment (as % of female employment) of Industry and Employment (as % of female employment) of Services?
Your answer should be compact. -71.7. In the year 1993, what is the difference between the Employment (as % of female employment) of Services and Employment (as % of female employment) of Self-employed?
Make the answer very short. 78.8. In the year 1994, what is the difference between the Employment (as % of female employment) in Agriculture and Employment (as % of female employment) in Services?
Offer a very short reply. -83.4. In the year 1994, what is the difference between the Employment (as % of female employment) of Industry and Employment (as % of female employment) of Services?
Give a very brief answer. -71.6. In the year 1994, what is the difference between the Employment (as % of female employment) of Industry and Employment (as % of female employment) of Self-employed?
Offer a very short reply. 6.3. In the year 1994, what is the difference between the Employment (as % of female employment) in Services and Employment (as % of female employment) in Self-employed?
Make the answer very short. 77.9. In the year 1995, what is the difference between the Employment (as % of female employment) of Agriculture and Employment (as % of female employment) of Services?
Ensure brevity in your answer.  -83.6. In the year 1995, what is the difference between the Employment (as % of female employment) of Industry and Employment (as % of female employment) of Services?
Provide a short and direct response. -72. In the year 1995, what is the difference between the Employment (as % of female employment) of Services and Employment (as % of female employment) of Self-employed?
Your answer should be very brief. 78.3. In the year 1996, what is the difference between the Employment (as % of female employment) in Agriculture and Employment (as % of female employment) in Industry?
Your answer should be compact. -11.7. In the year 1996, what is the difference between the Employment (as % of female employment) of Agriculture and Employment (as % of female employment) of Services?
Provide a succinct answer. -83.8. In the year 1996, what is the difference between the Employment (as % of female employment) of Agriculture and Employment (as % of female employment) of Self-employed?
Your response must be concise. -5.4. In the year 1996, what is the difference between the Employment (as % of female employment) in Industry and Employment (as % of female employment) in Services?
Offer a very short reply. -72.1. In the year 1996, what is the difference between the Employment (as % of female employment) in Services and Employment (as % of female employment) in Self-employed?
Provide a succinct answer. 78.4. What is the ratio of the Employment (as % of female employment) in Self-employed in 1988 to that in 1989?
Your answer should be very brief. 1. What is the ratio of the Employment (as % of female employment) in Agriculture in 1988 to that in 1990?
Offer a terse response. 1.08. What is the ratio of the Employment (as % of female employment) in Industry in 1988 to that in 1990?
Provide a short and direct response. 1.06. What is the ratio of the Employment (as % of female employment) in Services in 1988 to that in 1990?
Your response must be concise. 0.99. What is the ratio of the Employment (as % of female employment) in Self-employed in 1988 to that in 1990?
Your response must be concise. 1.01. What is the ratio of the Employment (as % of female employment) of Industry in 1988 to that in 1991?
Make the answer very short. 1.09. What is the ratio of the Employment (as % of female employment) of Services in 1988 to that in 1991?
Your response must be concise. 0.99. What is the ratio of the Employment (as % of female employment) of Self-employed in 1988 to that in 1991?
Your answer should be very brief. 1. What is the ratio of the Employment (as % of female employment) of Agriculture in 1988 to that in 1992?
Offer a very short reply. 1.08. What is the ratio of the Employment (as % of female employment) of Industry in 1988 to that in 1992?
Keep it short and to the point. 1.11. What is the ratio of the Employment (as % of female employment) in Services in 1988 to that in 1992?
Offer a terse response. 0.98. What is the ratio of the Employment (as % of female employment) in Self-employed in 1988 to that in 1992?
Ensure brevity in your answer.  1.06. What is the ratio of the Employment (as % of female employment) of Industry in 1988 to that in 1993?
Your answer should be compact. 1.17. What is the ratio of the Employment (as % of female employment) of Industry in 1988 to that in 1994?
Give a very brief answer. 1.18. What is the ratio of the Employment (as % of female employment) in Services in 1988 to that in 1994?
Offer a terse response. 0.98. What is the ratio of the Employment (as % of female employment) of Self-employed in 1988 to that in 1994?
Make the answer very short. 0.96. What is the ratio of the Employment (as % of female employment) in Agriculture in 1988 to that in 1995?
Ensure brevity in your answer.  0.88. What is the ratio of the Employment (as % of female employment) in Industry in 1988 to that in 1995?
Offer a very short reply. 1.2. What is the ratio of the Employment (as % of female employment) in Self-employed in 1988 to that in 1995?
Give a very brief answer. 0.99. What is the ratio of the Employment (as % of female employment) of Industry in 1988 to that in 1996?
Your answer should be compact. 1.2. What is the ratio of the Employment (as % of female employment) in Services in 1988 to that in 1996?
Provide a short and direct response. 0.97. What is the ratio of the Employment (as % of female employment) of Self-employed in 1988 to that in 1996?
Ensure brevity in your answer.  0.99. What is the ratio of the Employment (as % of female employment) in Industry in 1989 to that in 1990?
Provide a short and direct response. 1.03. What is the ratio of the Employment (as % of female employment) in Self-employed in 1989 to that in 1990?
Your response must be concise. 1.01. What is the ratio of the Employment (as % of female employment) in Agriculture in 1989 to that in 1991?
Keep it short and to the point. 1.08. What is the ratio of the Employment (as % of female employment) in Industry in 1989 to that in 1991?
Provide a short and direct response. 1.06. What is the ratio of the Employment (as % of female employment) of Services in 1989 to that in 1991?
Ensure brevity in your answer.  0.99. What is the ratio of the Employment (as % of female employment) of Self-employed in 1989 to that in 1991?
Make the answer very short. 1. What is the ratio of the Employment (as % of female employment) in Industry in 1989 to that in 1992?
Your answer should be compact. 1.08. What is the ratio of the Employment (as % of female employment) of Services in 1989 to that in 1992?
Your answer should be very brief. 0.98. What is the ratio of the Employment (as % of female employment) in Self-employed in 1989 to that in 1992?
Ensure brevity in your answer.  1.06. What is the ratio of the Employment (as % of female employment) of Agriculture in 1989 to that in 1993?
Your answer should be compact. 1.17. What is the ratio of the Employment (as % of female employment) in Industry in 1989 to that in 1993?
Your answer should be compact. 1.14. What is the ratio of the Employment (as % of female employment) of Services in 1989 to that in 1993?
Provide a short and direct response. 0.98. What is the ratio of the Employment (as % of female employment) of Self-employed in 1989 to that in 1993?
Your answer should be compact. 1.06. What is the ratio of the Employment (as % of female employment) of Industry in 1989 to that in 1994?
Offer a terse response. 1.15. What is the ratio of the Employment (as % of female employment) in Services in 1989 to that in 1994?
Keep it short and to the point. 0.98. What is the ratio of the Employment (as % of female employment) of Self-employed in 1989 to that in 1994?
Keep it short and to the point. 0.96. What is the ratio of the Employment (as % of female employment) of Industry in 1989 to that in 1995?
Keep it short and to the point. 1.17. What is the ratio of the Employment (as % of female employment) in Services in 1989 to that in 1995?
Offer a terse response. 0.98. What is the ratio of the Employment (as % of female employment) of Self-employed in 1989 to that in 1995?
Give a very brief answer. 0.99. What is the ratio of the Employment (as % of female employment) in Industry in 1989 to that in 1996?
Keep it short and to the point. 1.17. What is the ratio of the Employment (as % of female employment) in Services in 1989 to that in 1996?
Provide a short and direct response. 0.98. What is the ratio of the Employment (as % of female employment) of Self-employed in 1989 to that in 1996?
Offer a terse response. 0.99. What is the ratio of the Employment (as % of female employment) of Industry in 1990 to that in 1991?
Your answer should be compact. 1.03. What is the ratio of the Employment (as % of female employment) in Agriculture in 1990 to that in 1992?
Keep it short and to the point. 1. What is the ratio of the Employment (as % of female employment) of Industry in 1990 to that in 1992?
Keep it short and to the point. 1.05. What is the ratio of the Employment (as % of female employment) in Self-employed in 1990 to that in 1992?
Your answer should be compact. 1.05. What is the ratio of the Employment (as % of female employment) of Agriculture in 1990 to that in 1993?
Keep it short and to the point. 1.08. What is the ratio of the Employment (as % of female employment) of Industry in 1990 to that in 1993?
Ensure brevity in your answer.  1.1. What is the ratio of the Employment (as % of female employment) of Services in 1990 to that in 1993?
Provide a short and direct response. 0.98. What is the ratio of the Employment (as % of female employment) of Self-employed in 1990 to that in 1993?
Offer a terse response. 1.05. What is the ratio of the Employment (as % of female employment) in Agriculture in 1990 to that in 1994?
Provide a succinct answer. 0.81. What is the ratio of the Employment (as % of female employment) in Industry in 1990 to that in 1994?
Keep it short and to the point. 1.11. What is the ratio of the Employment (as % of female employment) in Services in 1990 to that in 1994?
Offer a terse response. 0.99. What is the ratio of the Employment (as % of female employment) in Self-employed in 1990 to that in 1994?
Your answer should be compact. 0.94. What is the ratio of the Employment (as % of female employment) in Agriculture in 1990 to that in 1995?
Provide a succinct answer. 0.81. What is the ratio of the Employment (as % of female employment) in Industry in 1990 to that in 1995?
Give a very brief answer. 1.13. What is the ratio of the Employment (as % of female employment) of Services in 1990 to that in 1995?
Ensure brevity in your answer.  0.98. What is the ratio of the Employment (as % of female employment) of Self-employed in 1990 to that in 1995?
Your answer should be compact. 0.97. What is the ratio of the Employment (as % of female employment) of Agriculture in 1990 to that in 1996?
Make the answer very short. 0.87. What is the ratio of the Employment (as % of female employment) of Industry in 1990 to that in 1996?
Offer a terse response. 1.13. What is the ratio of the Employment (as % of female employment) of Services in 1990 to that in 1996?
Give a very brief answer. 0.98. What is the ratio of the Employment (as % of female employment) of Self-employed in 1990 to that in 1996?
Make the answer very short. 0.97. What is the ratio of the Employment (as % of female employment) in Industry in 1991 to that in 1992?
Offer a terse response. 1.02. What is the ratio of the Employment (as % of female employment) of Services in 1991 to that in 1992?
Ensure brevity in your answer.  1. What is the ratio of the Employment (as % of female employment) in Self-employed in 1991 to that in 1992?
Provide a succinct answer. 1.06. What is the ratio of the Employment (as % of female employment) in Industry in 1991 to that in 1993?
Your response must be concise. 1.07. What is the ratio of the Employment (as % of female employment) of Services in 1991 to that in 1993?
Keep it short and to the point. 0.99. What is the ratio of the Employment (as % of female employment) in Agriculture in 1991 to that in 1994?
Your answer should be very brief. 0.81. What is the ratio of the Employment (as % of female employment) in Industry in 1991 to that in 1994?
Offer a terse response. 1.08. What is the ratio of the Employment (as % of female employment) in Self-employed in 1991 to that in 1994?
Provide a short and direct response. 0.96. What is the ratio of the Employment (as % of female employment) in Agriculture in 1991 to that in 1995?
Ensure brevity in your answer.  0.81. What is the ratio of the Employment (as % of female employment) of Industry in 1991 to that in 1995?
Your answer should be very brief. 1.1. What is the ratio of the Employment (as % of female employment) in Services in 1991 to that in 1995?
Give a very brief answer. 0.99. What is the ratio of the Employment (as % of female employment) in Self-employed in 1991 to that in 1995?
Your answer should be very brief. 0.99. What is the ratio of the Employment (as % of female employment) of Agriculture in 1991 to that in 1996?
Make the answer very short. 0.87. What is the ratio of the Employment (as % of female employment) in Industry in 1991 to that in 1996?
Your response must be concise. 1.1. What is the ratio of the Employment (as % of female employment) in Services in 1991 to that in 1996?
Offer a terse response. 0.99. What is the ratio of the Employment (as % of female employment) in Self-employed in 1991 to that in 1996?
Provide a succinct answer. 0.99. What is the ratio of the Employment (as % of female employment) in Industry in 1992 to that in 1993?
Make the answer very short. 1.05. What is the ratio of the Employment (as % of female employment) in Agriculture in 1992 to that in 1994?
Keep it short and to the point. 0.81. What is the ratio of the Employment (as % of female employment) in Industry in 1992 to that in 1994?
Offer a terse response. 1.06. What is the ratio of the Employment (as % of female employment) of Services in 1992 to that in 1994?
Offer a terse response. 0.99. What is the ratio of the Employment (as % of female employment) in Self-employed in 1992 to that in 1994?
Your response must be concise. 0.9. What is the ratio of the Employment (as % of female employment) of Agriculture in 1992 to that in 1995?
Your answer should be very brief. 0.81. What is the ratio of the Employment (as % of female employment) in Industry in 1992 to that in 1995?
Your response must be concise. 1.08. What is the ratio of the Employment (as % of female employment) of Self-employed in 1992 to that in 1995?
Provide a short and direct response. 0.93. What is the ratio of the Employment (as % of female employment) in Agriculture in 1992 to that in 1996?
Your answer should be very brief. 0.87. What is the ratio of the Employment (as % of female employment) of Industry in 1992 to that in 1996?
Provide a succinct answer. 1.08. What is the ratio of the Employment (as % of female employment) of Services in 1992 to that in 1996?
Your answer should be very brief. 0.99. What is the ratio of the Employment (as % of female employment) of Self-employed in 1992 to that in 1996?
Your response must be concise. 0.93. What is the ratio of the Employment (as % of female employment) in Industry in 1993 to that in 1994?
Offer a terse response. 1.01. What is the ratio of the Employment (as % of female employment) of Self-employed in 1993 to that in 1994?
Keep it short and to the point. 0.9. What is the ratio of the Employment (as % of female employment) of Agriculture in 1993 to that in 1995?
Keep it short and to the point. 0.75. What is the ratio of the Employment (as % of female employment) in Industry in 1993 to that in 1995?
Provide a short and direct response. 1.02. What is the ratio of the Employment (as % of female employment) in Services in 1993 to that in 1995?
Offer a terse response. 1. What is the ratio of the Employment (as % of female employment) in Self-employed in 1993 to that in 1995?
Your answer should be compact. 0.93. What is the ratio of the Employment (as % of female employment) in Agriculture in 1993 to that in 1996?
Give a very brief answer. 0.8. What is the ratio of the Employment (as % of female employment) of Industry in 1993 to that in 1996?
Your response must be concise. 1.02. What is the ratio of the Employment (as % of female employment) in Self-employed in 1993 to that in 1996?
Ensure brevity in your answer.  0.93. What is the ratio of the Employment (as % of female employment) in Industry in 1994 to that in 1995?
Provide a succinct answer. 1.02. What is the ratio of the Employment (as % of female employment) in Agriculture in 1994 to that in 1996?
Your answer should be compact. 1.07. What is the ratio of the Employment (as % of female employment) of Industry in 1994 to that in 1996?
Make the answer very short. 1.02. What is the ratio of the Employment (as % of female employment) in Self-employed in 1994 to that in 1996?
Your answer should be very brief. 1.03. What is the ratio of the Employment (as % of female employment) of Agriculture in 1995 to that in 1996?
Your answer should be very brief. 1.07. What is the ratio of the Employment (as % of female employment) of Services in 1995 to that in 1996?
Your response must be concise. 1. What is the difference between the highest and the second highest Employment (as % of female employment) of Industry?
Make the answer very short. 0.4. 